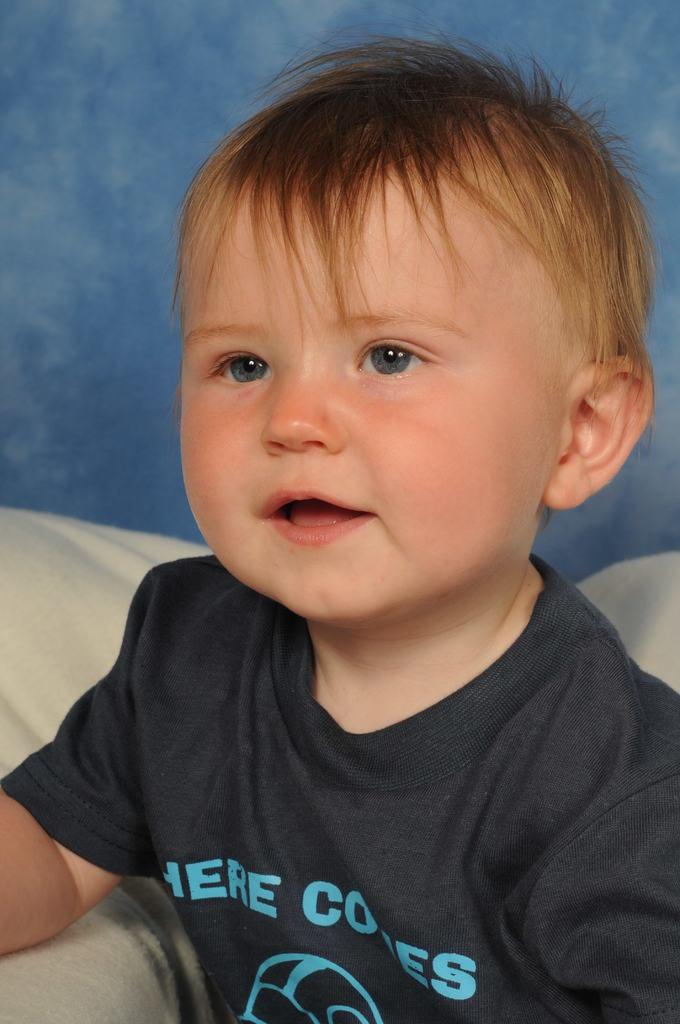What is the main subject of the image? The main subject of the image is a kid. Where is the kid located in the image? The kid is sitting on a sofa. What can be seen in the background of the image? There is a wall in the image. Can you describe the setting of the image? The image may have been taken in a room. What type of map can be seen on the wall in the image? There is no map present on the wall in the image. What is the texture of the lift in the image? There is no lift present in the image. 